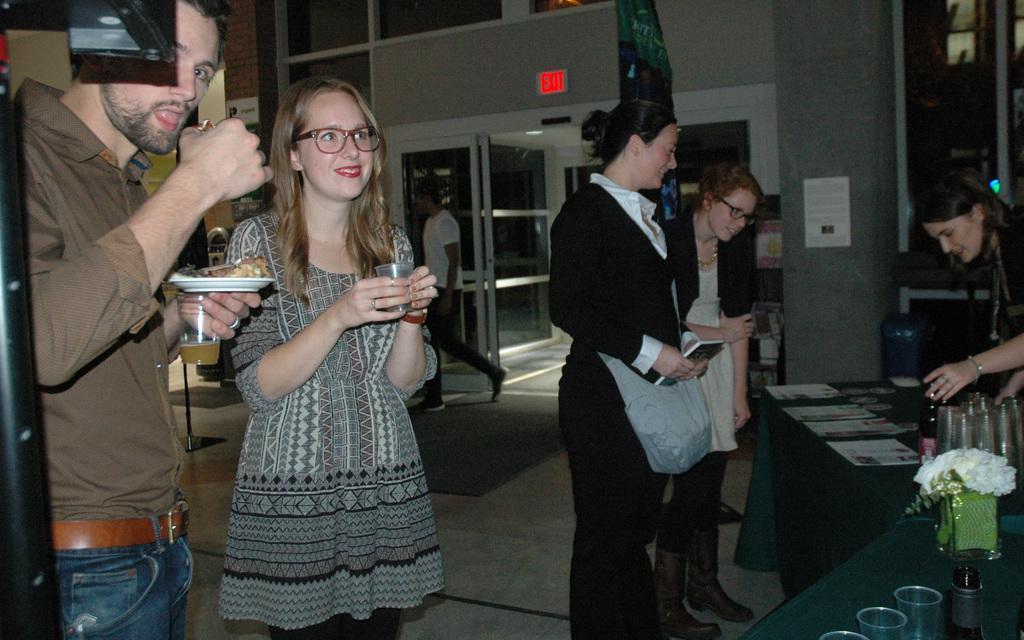Describe this image in one or two sentences. In this image we can see few persons are standing and among them a man on the left side is holding food item in a plate and glass and another persons are holding glasses and objects. On the tables we can see glasses, flower vase and objects. In the background we can see a person, doors, glasses and objects on the wall. 